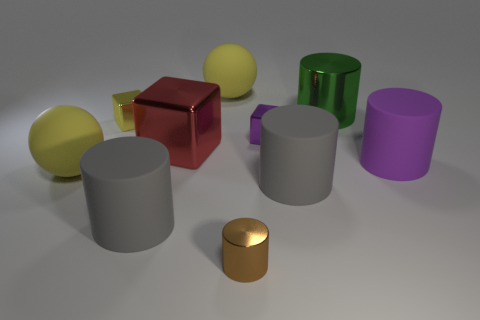Subtract all brown cylinders. How many cylinders are left? 4 Subtract all large shiny cylinders. How many cylinders are left? 4 Subtract all purple cylinders. Subtract all gray spheres. How many cylinders are left? 4 Subtract all blocks. How many objects are left? 7 Add 1 yellow balls. How many yellow balls are left? 3 Add 7 big red shiny objects. How many big red shiny objects exist? 8 Subtract 1 green cylinders. How many objects are left? 9 Subtract all tiny brown cylinders. Subtract all tiny brown cylinders. How many objects are left? 8 